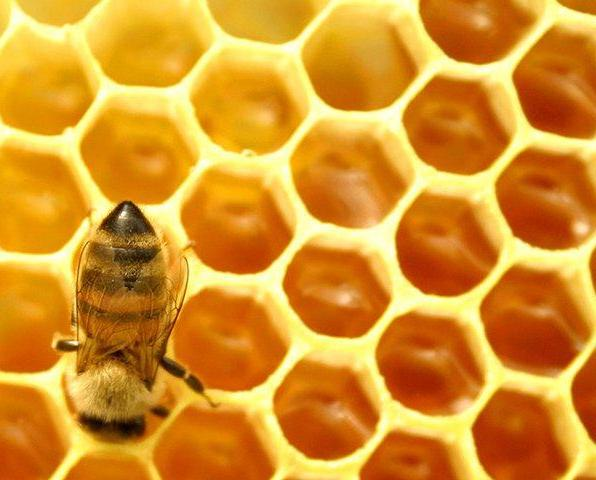How does the texture of the honeycomb affect its usefulness to the bees? The honeycomb's smooth, waxy texture is vital for its use by bees. This texture serves multiple purposes: it helps in minimizing the wax needed for structural stability, maximizes space efficiency with its geometric shape, and prevents honey from leaking, ensuring that the honey stored within the comb remains uncontaminated and conserved. The slick surface also allows bees to move easily over it without getting stuck. 